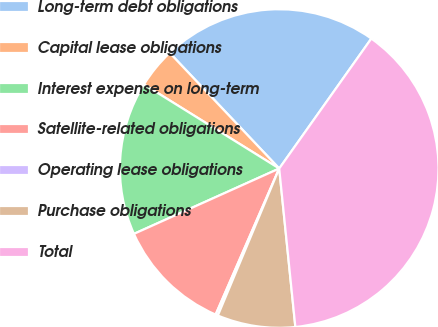Convert chart to OTSL. <chart><loc_0><loc_0><loc_500><loc_500><pie_chart><fcel>Long-term debt obligations<fcel>Capital lease obligations<fcel>Interest expense on long-term<fcel>Satellite-related obligations<fcel>Operating lease obligations<fcel>Purchase obligations<fcel>Total<nl><fcel>21.88%<fcel>4.08%<fcel>15.58%<fcel>11.74%<fcel>0.24%<fcel>7.91%<fcel>38.57%<nl></chart> 